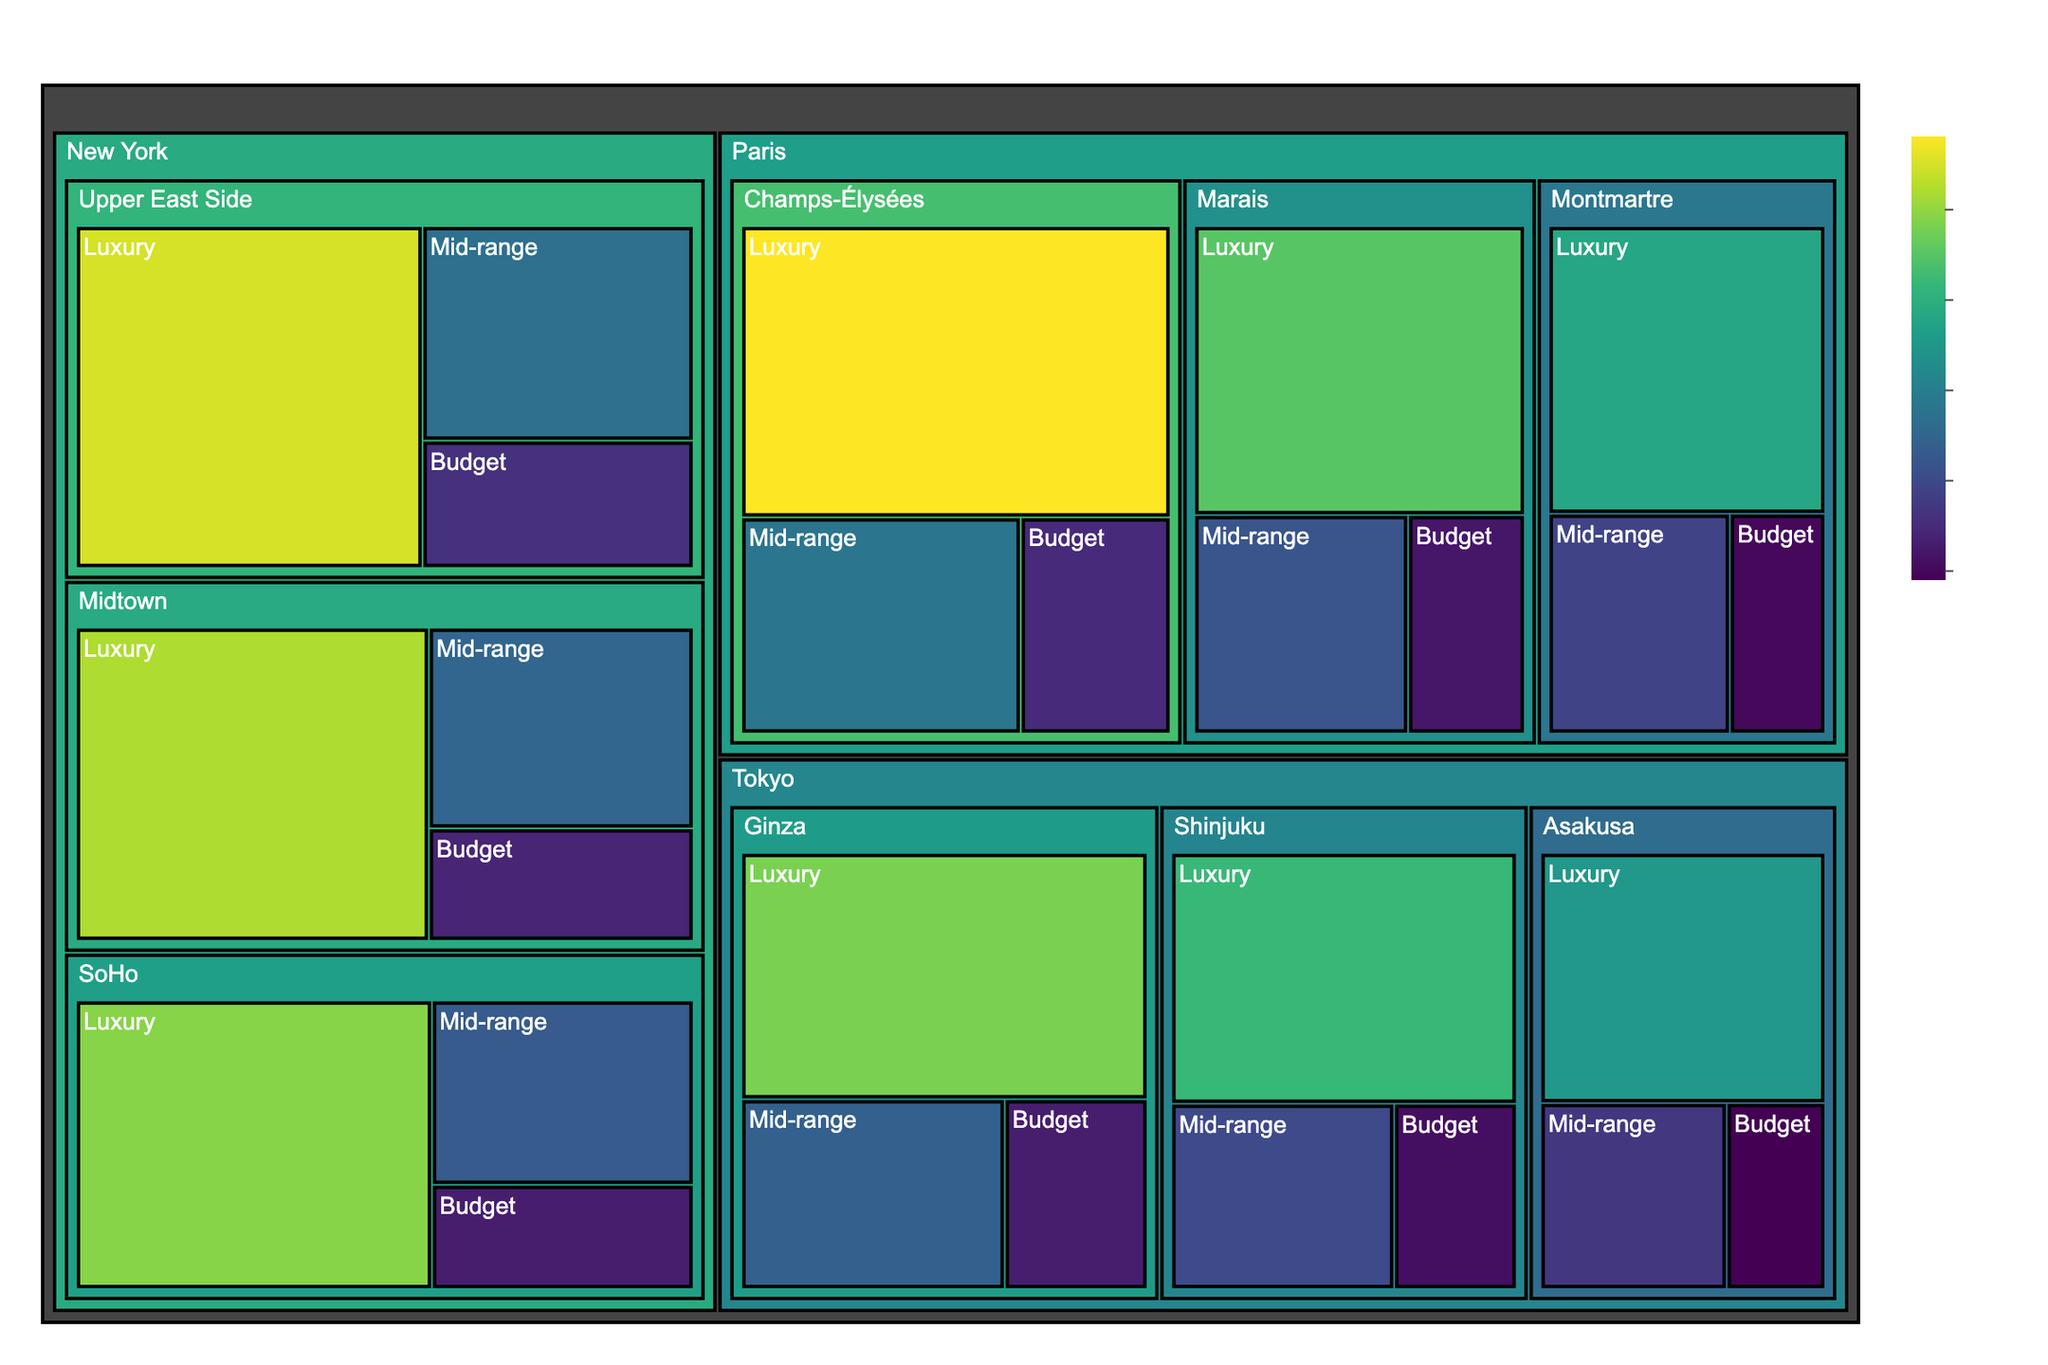What's the title of the figure? The title of a plot is usually located at the top and it gives a brief description of what the plot represents. Here it is "Hotel Room Prices in Major Tourist Cities" which tells us the data shown is about room prices in different tourist cities.
Answer: Hotel Room Prices in Major Tourist Cities Which neighborhood in Paris has the highest luxury hotel price? To find the highest luxury hotel price in Paris, we look at the "Luxury" category within Paris neighborhoods. The prices are 450 for Marais, 580 for Champs-Élysées, and 380 for Montmartre. The highest value is 580 in Champs-Élysées.
Answer: Champs-Élysées What is the average price of mid-range hotels in New York? The mid-range hotel prices in New York neighborhoods are 250 for Midtown, 230 for SoHo, and 270 for Upper East Side. Summing these gives 250 + 230 + 270 = 750 and their average is 750/3 = 250.
Answer: 250 Compare the budget hotel prices between Tokyo and Paris, which city has the lower average price? The budget hotel prices in Tokyo neighborhoods are 110 (Shinjuku), 130 (Ginza), and 90 (Asakusa) summing to 330, with an average of 330/3 = 110. The budget hotel prices in Paris neighborhoods are 120 (Marais), 150 (Champs-Élysées), and 100 (Montmartre) summing to 370, with an average of 370/3 ≈ 123.3. Tokyo has the lower average price.
Answer: Tokyo Which city has the highest overall hotel price, considering all categories? We need to compare the highest prices from all categories between the cities. The highest prices in each city based on Luxury hotels are 580 (Paris), 550 (New York), and 480 (Tokyo). The highest overall price is 580 in Paris.
Answer: Paris How many neighborhoods in New York have luxury hotel prices above 500? The luxury hotel prices in New York's neighborhoods are 520 (Midtown), 490 (SoHo), and 550 (Upper East Side). Two neighborhoods (Midtown and Upper East Side) have prices above 500.
Answer: 2 What's the price difference between the luxury hotels in Midtown, New York, and Shinjuku, Tokyo? The luxury hotel price in Midtown, New York is 520 and in Shinjuku, Tokyo is 420. The difference is 520 - 420 = 100.
Answer: 100 Which city has the highest mid-range hotel price? The mid-range hotel prices in each city are found by looking for the highest values in the "Mid-range" category for each city: Paris (Marais: 220, Champs-Élysées: 280, Montmartre: 190), New York (Midtown: 250, SoHo: 230, Upper East Side: 270), and Tokyo (Shinjuku: 200, Ginza: 240, Asakusa: 170). The highest price is 280 from Champs-Élysées in Paris.
Answer: Paris 